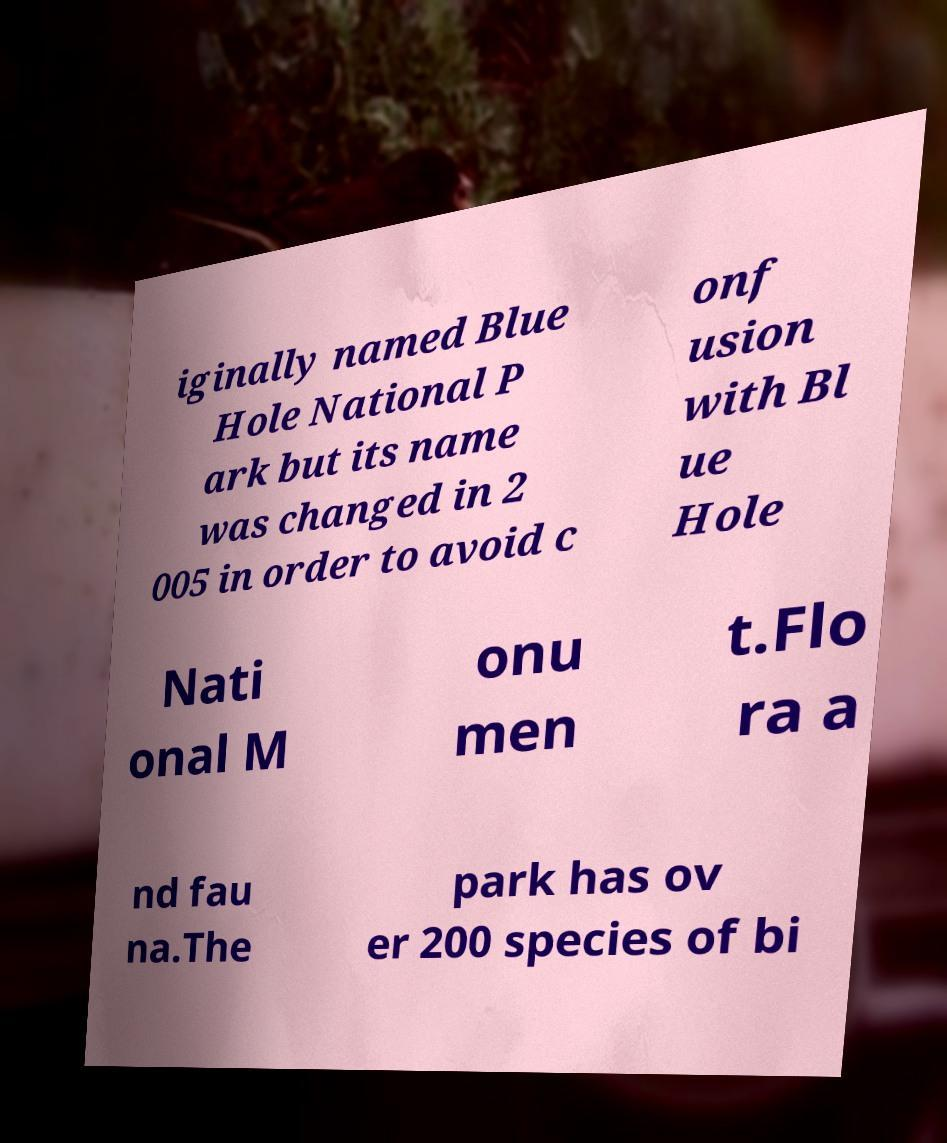For documentation purposes, I need the text within this image transcribed. Could you provide that? iginally named Blue Hole National P ark but its name was changed in 2 005 in order to avoid c onf usion with Bl ue Hole Nati onal M onu men t.Flo ra a nd fau na.The park has ov er 200 species of bi 